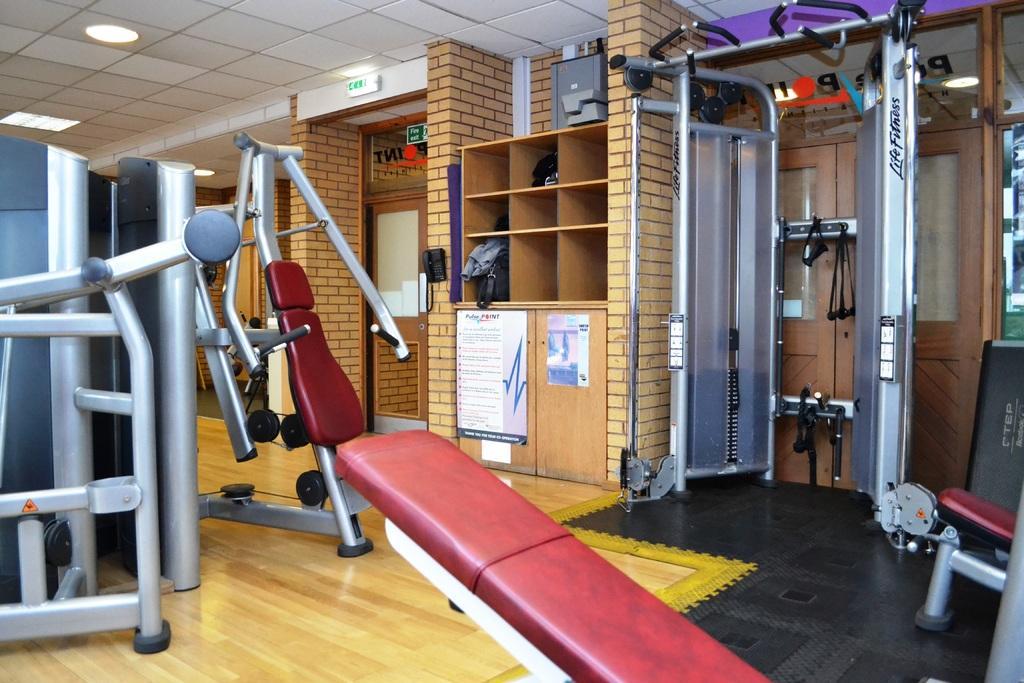Please provide a concise description of this image. This is an inside view of a room. Here I can see the gym equipment. In the background there are few doors to the wall. In the middle of the image there is a rack in which few objects are placed and there are few posts attached to a cupboard. At the top of the image there are few lights attached to the ceiling. 